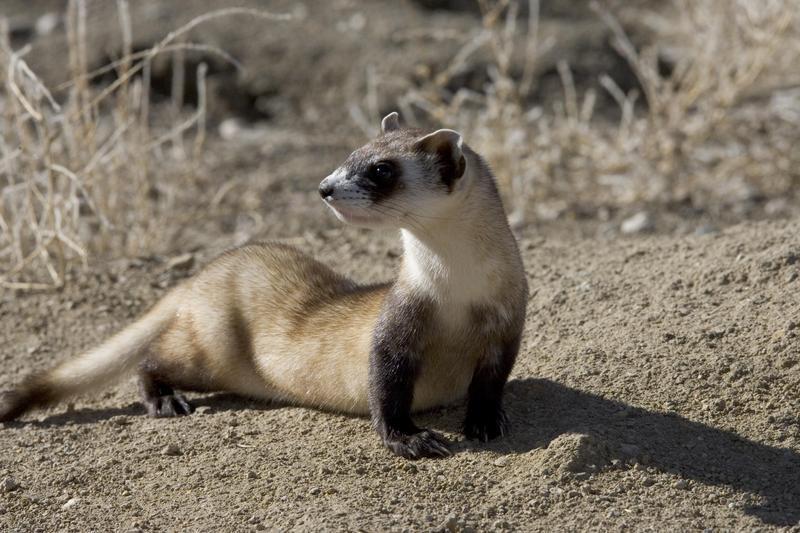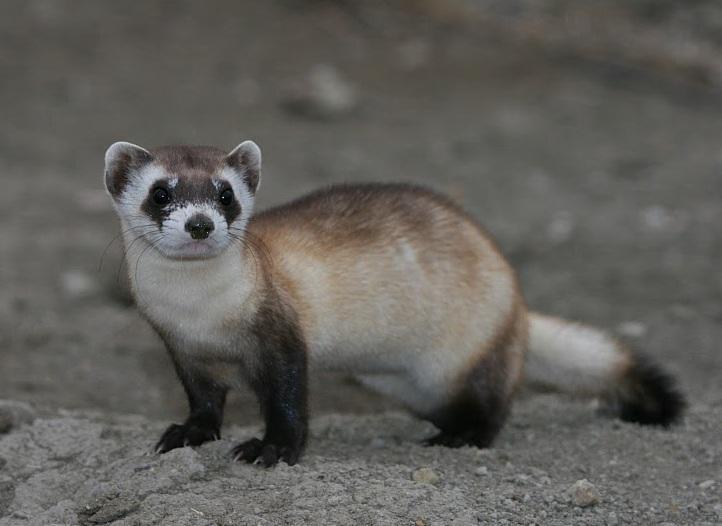The first image is the image on the left, the second image is the image on the right. Evaluate the accuracy of this statement regarding the images: "There are at least two animals in the image on the right.". Is it true? Answer yes or no. No. The first image is the image on the left, the second image is the image on the right. Considering the images on both sides, is "An animal is looking to the left." valid? Answer yes or no. Yes. The first image is the image on the left, the second image is the image on the right. Given the left and right images, does the statement "Right and left images show ferrets with heads facing the same direction." hold true? Answer yes or no. No. 